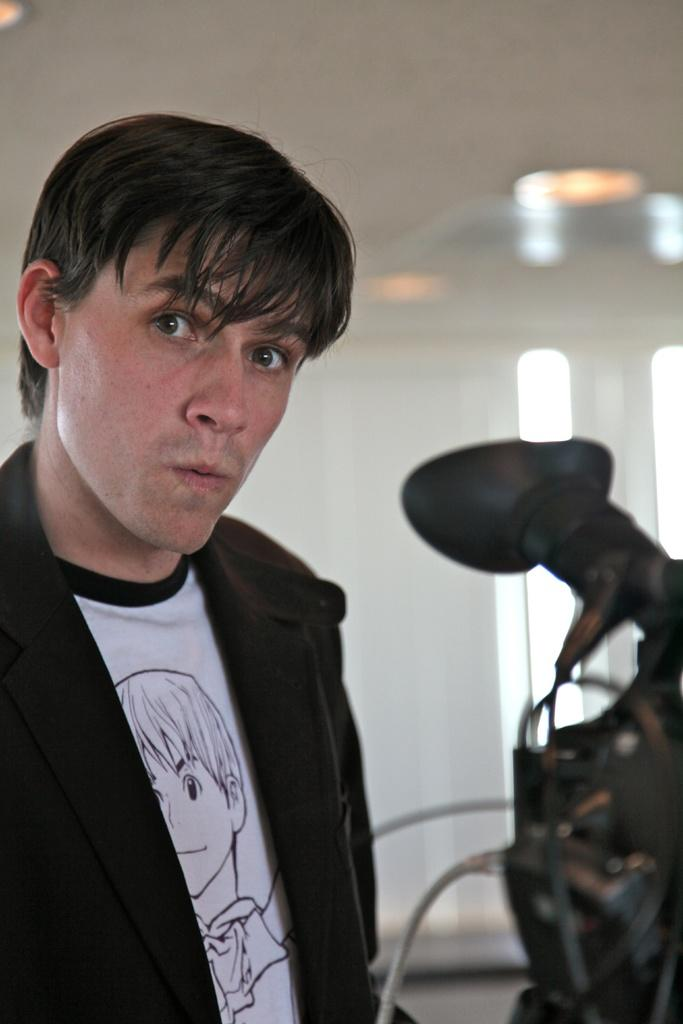Who or what is on the left side of the image? There is a person on the left side of the image. What can be seen at the top of the image? There is a light visible at the top of the image. How many cows are grazing in the territory shown in the image? There are no cows or territory present in the image. What type of basket is being used by the person in the image? There is no basket visible in the image. 